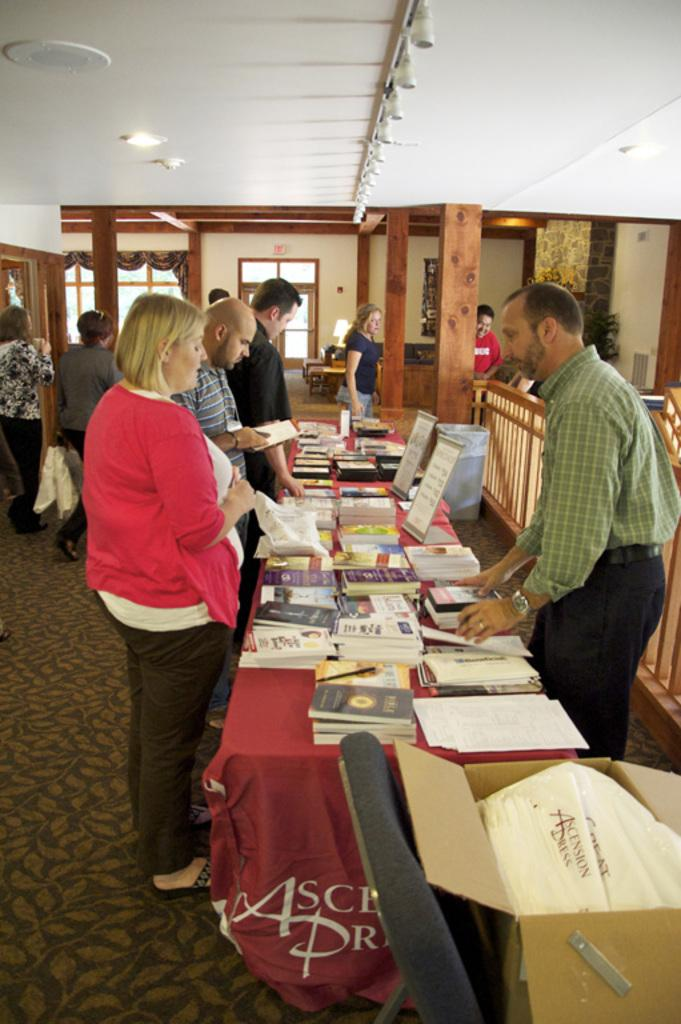What type of space is depicted in the image? There is a room in the image. What can be seen inside the room? There is a group of people in the room, and they are standing. What furniture is present in the room? There is a table in the room. What items are on the table? There are books on the table. What can be seen in the background of the room? There is a white-colored roof, a curtain, and a window visible in the background. What type of chair is on fire in the image? There is no chair or fire present in the image. 